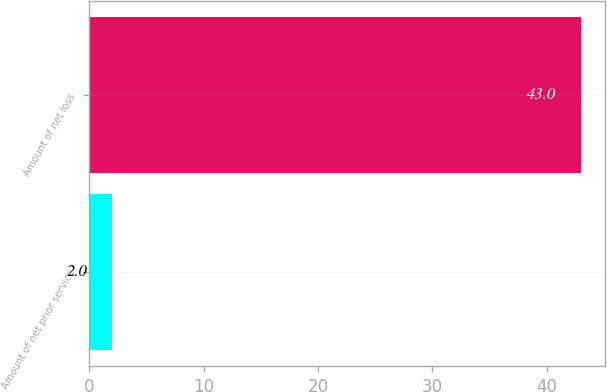Convert chart to OTSL. <chart><loc_0><loc_0><loc_500><loc_500><bar_chart><fcel>Amount of net prior service<fcel>Amount of net loss<nl><fcel>2<fcel>43<nl></chart> 